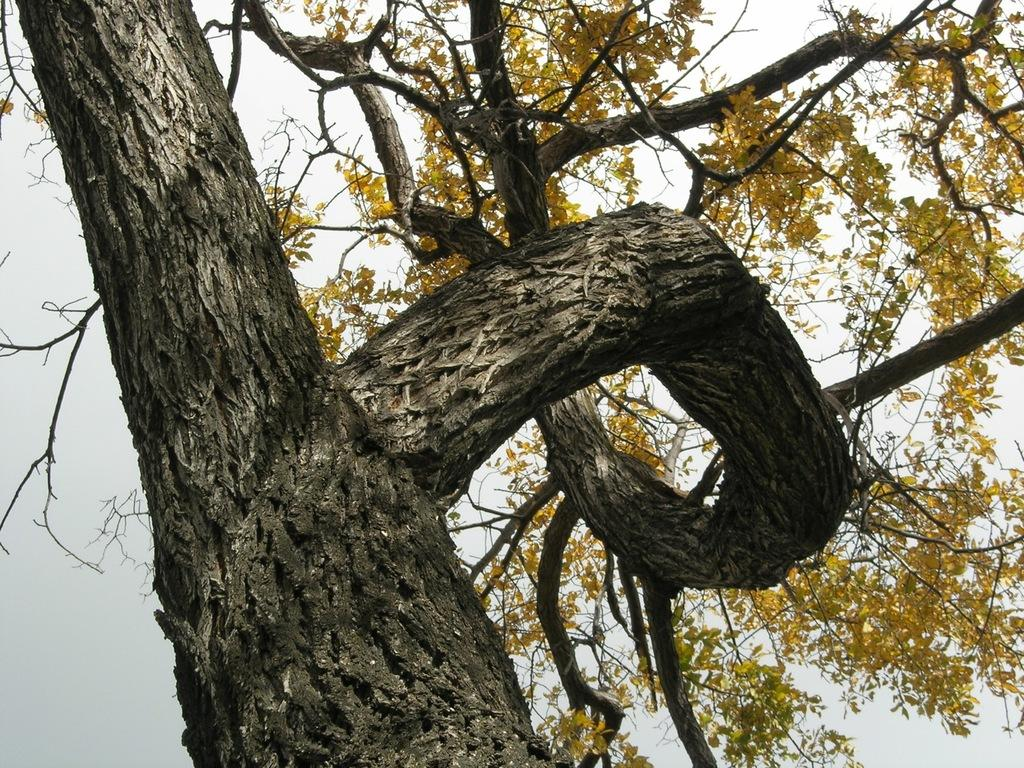What is located in the foreground of the image? There is a tree in the foreground of the image. What can be seen in the background of the image? The sky is visible in the background of the image. What type of dinner is being served on the tray in the image? There is no tray or dinner present in the image; it features a tree in the foreground and the sky in the background. Can you tell me how many volleyballs are visible in the image? There are no volleyballs present in the image. 